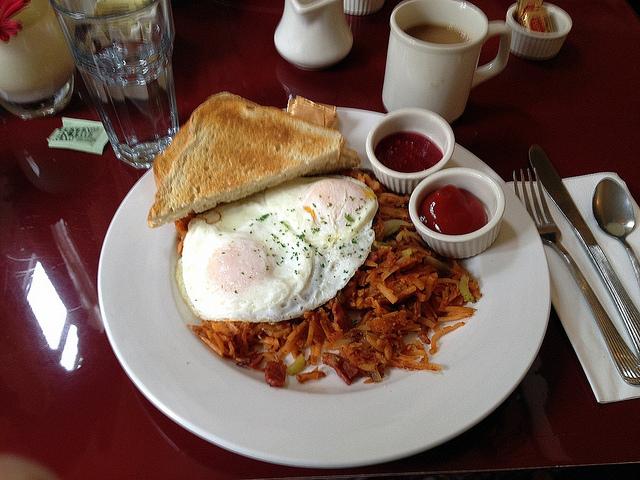What is this?
Give a very brief answer. Breakfast. How many spoons are on the table?
Keep it brief. 1. Are there any eggs on the plate?
Quick response, please. Yes. What meal of the day is this?
Answer briefly. Breakfast. 